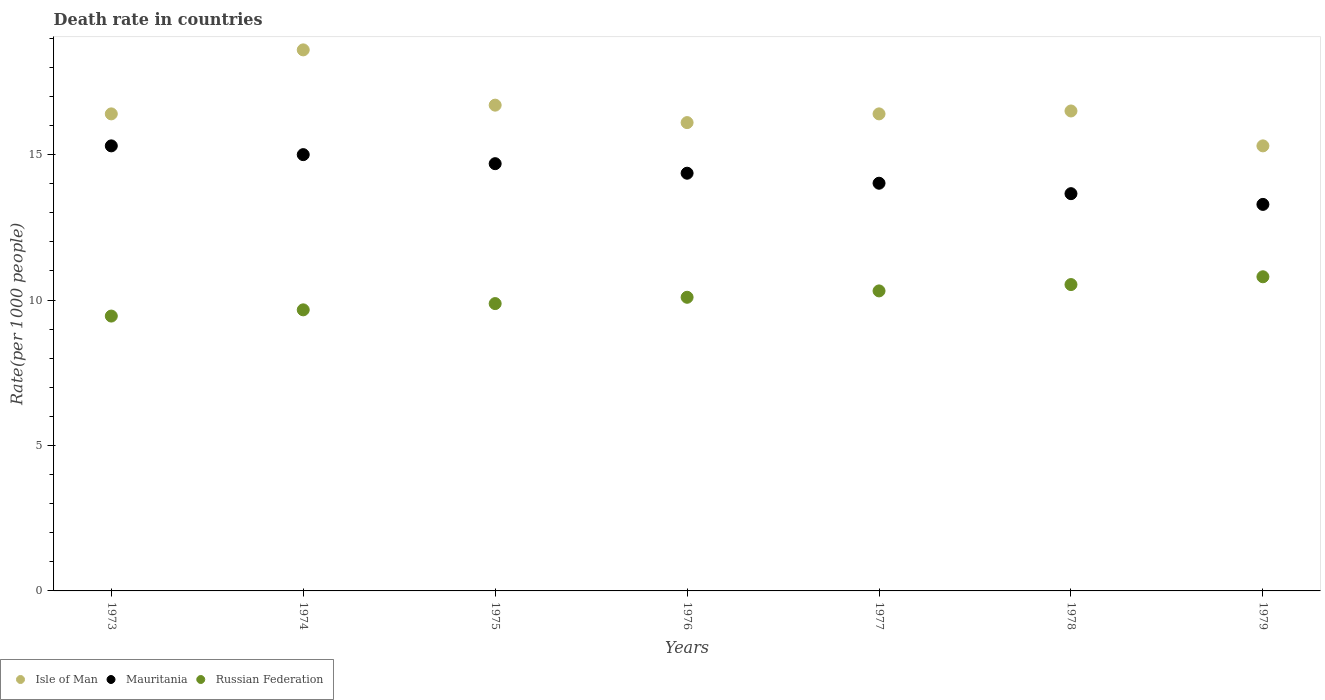How many different coloured dotlines are there?
Your response must be concise. 3. Is the number of dotlines equal to the number of legend labels?
Provide a succinct answer. Yes. What is the death rate in Mauritania in 1977?
Your answer should be very brief. 14.02. Across all years, what is the minimum death rate in Russian Federation?
Your answer should be compact. 9.45. In which year was the death rate in Russian Federation maximum?
Provide a short and direct response. 1979. What is the total death rate in Isle of Man in the graph?
Your answer should be compact. 116. What is the difference between the death rate in Isle of Man in 1973 and that in 1974?
Provide a succinct answer. -2.2. What is the average death rate in Isle of Man per year?
Provide a succinct answer. 16.57. In the year 1976, what is the difference between the death rate in Mauritania and death rate in Russian Federation?
Your answer should be very brief. 4.26. What is the ratio of the death rate in Russian Federation in 1973 to that in 1978?
Make the answer very short. 0.9. Is the death rate in Russian Federation in 1974 less than that in 1978?
Your answer should be very brief. Yes. Is the difference between the death rate in Mauritania in 1973 and 1977 greater than the difference between the death rate in Russian Federation in 1973 and 1977?
Offer a terse response. Yes. What is the difference between the highest and the second highest death rate in Mauritania?
Ensure brevity in your answer.  0.3. What is the difference between the highest and the lowest death rate in Russian Federation?
Ensure brevity in your answer.  1.35. Is the sum of the death rate in Isle of Man in 1973 and 1978 greater than the maximum death rate in Mauritania across all years?
Your answer should be compact. Yes. Is it the case that in every year, the sum of the death rate in Russian Federation and death rate in Mauritania  is greater than the death rate in Isle of Man?
Give a very brief answer. Yes. Does the death rate in Russian Federation monotonically increase over the years?
Ensure brevity in your answer.  Yes. Is the death rate in Isle of Man strictly less than the death rate in Mauritania over the years?
Offer a very short reply. No. How many years are there in the graph?
Your response must be concise. 7. What is the difference between two consecutive major ticks on the Y-axis?
Give a very brief answer. 5. Are the values on the major ticks of Y-axis written in scientific E-notation?
Your response must be concise. No. Where does the legend appear in the graph?
Keep it short and to the point. Bottom left. What is the title of the graph?
Provide a succinct answer. Death rate in countries. Does "Japan" appear as one of the legend labels in the graph?
Your answer should be compact. No. What is the label or title of the X-axis?
Keep it short and to the point. Years. What is the label or title of the Y-axis?
Provide a short and direct response. Rate(per 1000 people). What is the Rate(per 1000 people) of Russian Federation in 1973?
Offer a terse response. 9.45. What is the Rate(per 1000 people) of Mauritania in 1974?
Ensure brevity in your answer.  15. What is the Rate(per 1000 people) in Russian Federation in 1974?
Provide a short and direct response. 9.66. What is the Rate(per 1000 people) of Mauritania in 1975?
Offer a very short reply. 14.69. What is the Rate(per 1000 people) in Russian Federation in 1975?
Ensure brevity in your answer.  9.88. What is the Rate(per 1000 people) of Mauritania in 1976?
Give a very brief answer. 14.36. What is the Rate(per 1000 people) of Russian Federation in 1976?
Offer a very short reply. 10.1. What is the Rate(per 1000 people) in Mauritania in 1977?
Your answer should be compact. 14.02. What is the Rate(per 1000 people) in Russian Federation in 1977?
Your answer should be very brief. 10.31. What is the Rate(per 1000 people) of Isle of Man in 1978?
Make the answer very short. 16.5. What is the Rate(per 1000 people) in Mauritania in 1978?
Offer a terse response. 13.66. What is the Rate(per 1000 people) of Russian Federation in 1978?
Provide a short and direct response. 10.53. What is the Rate(per 1000 people) of Isle of Man in 1979?
Keep it short and to the point. 15.3. What is the Rate(per 1000 people) in Mauritania in 1979?
Give a very brief answer. 13.29. What is the Rate(per 1000 people) of Russian Federation in 1979?
Provide a short and direct response. 10.8. Across all years, what is the maximum Rate(per 1000 people) of Russian Federation?
Keep it short and to the point. 10.8. Across all years, what is the minimum Rate(per 1000 people) in Mauritania?
Make the answer very short. 13.29. Across all years, what is the minimum Rate(per 1000 people) of Russian Federation?
Ensure brevity in your answer.  9.45. What is the total Rate(per 1000 people) in Isle of Man in the graph?
Keep it short and to the point. 116. What is the total Rate(per 1000 people) of Mauritania in the graph?
Your answer should be compact. 100.31. What is the total Rate(per 1000 people) in Russian Federation in the graph?
Offer a very short reply. 70.73. What is the difference between the Rate(per 1000 people) in Mauritania in 1973 and that in 1974?
Provide a succinct answer. 0.3. What is the difference between the Rate(per 1000 people) of Russian Federation in 1973 and that in 1974?
Keep it short and to the point. -0.21. What is the difference between the Rate(per 1000 people) in Mauritania in 1973 and that in 1975?
Make the answer very short. 0.61. What is the difference between the Rate(per 1000 people) in Russian Federation in 1973 and that in 1975?
Make the answer very short. -0.43. What is the difference between the Rate(per 1000 people) of Mauritania in 1973 and that in 1976?
Provide a succinct answer. 0.94. What is the difference between the Rate(per 1000 people) of Russian Federation in 1973 and that in 1976?
Offer a very short reply. -0.65. What is the difference between the Rate(per 1000 people) in Mauritania in 1973 and that in 1977?
Your response must be concise. 1.28. What is the difference between the Rate(per 1000 people) of Russian Federation in 1973 and that in 1977?
Your response must be concise. -0.86. What is the difference between the Rate(per 1000 people) in Isle of Man in 1973 and that in 1978?
Provide a short and direct response. -0.1. What is the difference between the Rate(per 1000 people) of Mauritania in 1973 and that in 1978?
Ensure brevity in your answer.  1.64. What is the difference between the Rate(per 1000 people) of Russian Federation in 1973 and that in 1978?
Offer a very short reply. -1.08. What is the difference between the Rate(per 1000 people) of Mauritania in 1973 and that in 1979?
Your answer should be very brief. 2.01. What is the difference between the Rate(per 1000 people) in Russian Federation in 1973 and that in 1979?
Your answer should be compact. -1.35. What is the difference between the Rate(per 1000 people) in Isle of Man in 1974 and that in 1975?
Give a very brief answer. 1.9. What is the difference between the Rate(per 1000 people) in Mauritania in 1974 and that in 1975?
Make the answer very short. 0.31. What is the difference between the Rate(per 1000 people) of Russian Federation in 1974 and that in 1975?
Your response must be concise. -0.21. What is the difference between the Rate(per 1000 people) of Isle of Man in 1974 and that in 1976?
Offer a terse response. 2.5. What is the difference between the Rate(per 1000 people) of Mauritania in 1974 and that in 1976?
Make the answer very short. 0.64. What is the difference between the Rate(per 1000 people) in Russian Federation in 1974 and that in 1976?
Ensure brevity in your answer.  -0.43. What is the difference between the Rate(per 1000 people) of Russian Federation in 1974 and that in 1977?
Your response must be concise. -0.65. What is the difference between the Rate(per 1000 people) in Mauritania in 1974 and that in 1978?
Keep it short and to the point. 1.34. What is the difference between the Rate(per 1000 people) in Russian Federation in 1974 and that in 1978?
Ensure brevity in your answer.  -0.87. What is the difference between the Rate(per 1000 people) in Mauritania in 1974 and that in 1979?
Make the answer very short. 1.71. What is the difference between the Rate(per 1000 people) in Russian Federation in 1974 and that in 1979?
Provide a succinct answer. -1.14. What is the difference between the Rate(per 1000 people) in Isle of Man in 1975 and that in 1976?
Your answer should be compact. 0.6. What is the difference between the Rate(per 1000 people) of Mauritania in 1975 and that in 1976?
Provide a succinct answer. 0.33. What is the difference between the Rate(per 1000 people) in Russian Federation in 1975 and that in 1976?
Offer a terse response. -0.22. What is the difference between the Rate(per 1000 people) of Isle of Man in 1975 and that in 1977?
Provide a succinct answer. 0.3. What is the difference between the Rate(per 1000 people) in Mauritania in 1975 and that in 1977?
Provide a short and direct response. 0.67. What is the difference between the Rate(per 1000 people) of Russian Federation in 1975 and that in 1977?
Make the answer very short. -0.44. What is the difference between the Rate(per 1000 people) of Mauritania in 1975 and that in 1978?
Your answer should be compact. 1.03. What is the difference between the Rate(per 1000 people) of Russian Federation in 1975 and that in 1978?
Make the answer very short. -0.65. What is the difference between the Rate(per 1000 people) of Mauritania in 1975 and that in 1979?
Give a very brief answer. 1.4. What is the difference between the Rate(per 1000 people) in Russian Federation in 1975 and that in 1979?
Provide a short and direct response. -0.92. What is the difference between the Rate(per 1000 people) of Mauritania in 1976 and that in 1977?
Offer a terse response. 0.34. What is the difference between the Rate(per 1000 people) in Russian Federation in 1976 and that in 1977?
Make the answer very short. -0.22. What is the difference between the Rate(per 1000 people) in Mauritania in 1976 and that in 1978?
Offer a very short reply. 0.7. What is the difference between the Rate(per 1000 people) in Russian Federation in 1976 and that in 1978?
Offer a very short reply. -0.44. What is the difference between the Rate(per 1000 people) in Isle of Man in 1976 and that in 1979?
Your response must be concise. 0.8. What is the difference between the Rate(per 1000 people) of Mauritania in 1976 and that in 1979?
Your answer should be compact. 1.07. What is the difference between the Rate(per 1000 people) in Russian Federation in 1976 and that in 1979?
Give a very brief answer. -0.7. What is the difference between the Rate(per 1000 people) of Mauritania in 1977 and that in 1978?
Give a very brief answer. 0.36. What is the difference between the Rate(per 1000 people) in Russian Federation in 1977 and that in 1978?
Keep it short and to the point. -0.22. What is the difference between the Rate(per 1000 people) in Mauritania in 1977 and that in 1979?
Keep it short and to the point. 0.73. What is the difference between the Rate(per 1000 people) in Russian Federation in 1977 and that in 1979?
Offer a very short reply. -0.49. What is the difference between the Rate(per 1000 people) of Isle of Man in 1978 and that in 1979?
Your answer should be very brief. 1.2. What is the difference between the Rate(per 1000 people) in Mauritania in 1978 and that in 1979?
Your answer should be compact. 0.37. What is the difference between the Rate(per 1000 people) of Russian Federation in 1978 and that in 1979?
Offer a very short reply. -0.27. What is the difference between the Rate(per 1000 people) in Isle of Man in 1973 and the Rate(per 1000 people) in Mauritania in 1974?
Provide a short and direct response. 1.4. What is the difference between the Rate(per 1000 people) of Isle of Man in 1973 and the Rate(per 1000 people) of Russian Federation in 1974?
Your answer should be very brief. 6.74. What is the difference between the Rate(per 1000 people) in Mauritania in 1973 and the Rate(per 1000 people) in Russian Federation in 1974?
Provide a succinct answer. 5.64. What is the difference between the Rate(per 1000 people) of Isle of Man in 1973 and the Rate(per 1000 people) of Mauritania in 1975?
Provide a short and direct response. 1.71. What is the difference between the Rate(per 1000 people) of Isle of Man in 1973 and the Rate(per 1000 people) of Russian Federation in 1975?
Offer a terse response. 6.52. What is the difference between the Rate(per 1000 people) in Mauritania in 1973 and the Rate(per 1000 people) in Russian Federation in 1975?
Provide a succinct answer. 5.42. What is the difference between the Rate(per 1000 people) of Isle of Man in 1973 and the Rate(per 1000 people) of Mauritania in 1976?
Provide a short and direct response. 2.04. What is the difference between the Rate(per 1000 people) in Isle of Man in 1973 and the Rate(per 1000 people) in Russian Federation in 1976?
Provide a short and direct response. 6.3. What is the difference between the Rate(per 1000 people) of Mauritania in 1973 and the Rate(per 1000 people) of Russian Federation in 1976?
Give a very brief answer. 5.21. What is the difference between the Rate(per 1000 people) in Isle of Man in 1973 and the Rate(per 1000 people) in Mauritania in 1977?
Your response must be concise. 2.38. What is the difference between the Rate(per 1000 people) of Isle of Man in 1973 and the Rate(per 1000 people) of Russian Federation in 1977?
Your response must be concise. 6.09. What is the difference between the Rate(per 1000 people) in Mauritania in 1973 and the Rate(per 1000 people) in Russian Federation in 1977?
Give a very brief answer. 4.99. What is the difference between the Rate(per 1000 people) in Isle of Man in 1973 and the Rate(per 1000 people) in Mauritania in 1978?
Your answer should be very brief. 2.74. What is the difference between the Rate(per 1000 people) in Isle of Man in 1973 and the Rate(per 1000 people) in Russian Federation in 1978?
Your answer should be compact. 5.87. What is the difference between the Rate(per 1000 people) of Mauritania in 1973 and the Rate(per 1000 people) of Russian Federation in 1978?
Provide a short and direct response. 4.77. What is the difference between the Rate(per 1000 people) of Isle of Man in 1973 and the Rate(per 1000 people) of Mauritania in 1979?
Your answer should be very brief. 3.11. What is the difference between the Rate(per 1000 people) in Isle of Man in 1973 and the Rate(per 1000 people) in Russian Federation in 1979?
Provide a short and direct response. 5.6. What is the difference between the Rate(per 1000 people) in Mauritania in 1973 and the Rate(per 1000 people) in Russian Federation in 1979?
Offer a very short reply. 4.5. What is the difference between the Rate(per 1000 people) in Isle of Man in 1974 and the Rate(per 1000 people) in Mauritania in 1975?
Provide a short and direct response. 3.91. What is the difference between the Rate(per 1000 people) in Isle of Man in 1974 and the Rate(per 1000 people) in Russian Federation in 1975?
Your answer should be very brief. 8.72. What is the difference between the Rate(per 1000 people) of Mauritania in 1974 and the Rate(per 1000 people) of Russian Federation in 1975?
Provide a succinct answer. 5.12. What is the difference between the Rate(per 1000 people) in Isle of Man in 1974 and the Rate(per 1000 people) in Mauritania in 1976?
Offer a terse response. 4.24. What is the difference between the Rate(per 1000 people) of Isle of Man in 1974 and the Rate(per 1000 people) of Russian Federation in 1976?
Offer a terse response. 8.51. What is the difference between the Rate(per 1000 people) of Mauritania in 1974 and the Rate(per 1000 people) of Russian Federation in 1976?
Provide a short and direct response. 4.9. What is the difference between the Rate(per 1000 people) in Isle of Man in 1974 and the Rate(per 1000 people) in Mauritania in 1977?
Provide a short and direct response. 4.58. What is the difference between the Rate(per 1000 people) in Isle of Man in 1974 and the Rate(per 1000 people) in Russian Federation in 1977?
Keep it short and to the point. 8.29. What is the difference between the Rate(per 1000 people) in Mauritania in 1974 and the Rate(per 1000 people) in Russian Federation in 1977?
Your answer should be very brief. 4.68. What is the difference between the Rate(per 1000 people) in Isle of Man in 1974 and the Rate(per 1000 people) in Mauritania in 1978?
Your answer should be compact. 4.94. What is the difference between the Rate(per 1000 people) of Isle of Man in 1974 and the Rate(per 1000 people) of Russian Federation in 1978?
Ensure brevity in your answer.  8.07. What is the difference between the Rate(per 1000 people) of Mauritania in 1974 and the Rate(per 1000 people) of Russian Federation in 1978?
Provide a succinct answer. 4.47. What is the difference between the Rate(per 1000 people) of Isle of Man in 1974 and the Rate(per 1000 people) of Mauritania in 1979?
Make the answer very short. 5.31. What is the difference between the Rate(per 1000 people) of Mauritania in 1974 and the Rate(per 1000 people) of Russian Federation in 1979?
Your response must be concise. 4.2. What is the difference between the Rate(per 1000 people) in Isle of Man in 1975 and the Rate(per 1000 people) in Mauritania in 1976?
Make the answer very short. 2.34. What is the difference between the Rate(per 1000 people) in Isle of Man in 1975 and the Rate(per 1000 people) in Russian Federation in 1976?
Provide a short and direct response. 6.61. What is the difference between the Rate(per 1000 people) in Mauritania in 1975 and the Rate(per 1000 people) in Russian Federation in 1976?
Offer a very short reply. 4.59. What is the difference between the Rate(per 1000 people) in Isle of Man in 1975 and the Rate(per 1000 people) in Mauritania in 1977?
Offer a terse response. 2.68. What is the difference between the Rate(per 1000 people) of Isle of Man in 1975 and the Rate(per 1000 people) of Russian Federation in 1977?
Keep it short and to the point. 6.39. What is the difference between the Rate(per 1000 people) of Mauritania in 1975 and the Rate(per 1000 people) of Russian Federation in 1977?
Your response must be concise. 4.37. What is the difference between the Rate(per 1000 people) of Isle of Man in 1975 and the Rate(per 1000 people) of Mauritania in 1978?
Your response must be concise. 3.04. What is the difference between the Rate(per 1000 people) of Isle of Man in 1975 and the Rate(per 1000 people) of Russian Federation in 1978?
Offer a very short reply. 6.17. What is the difference between the Rate(per 1000 people) in Mauritania in 1975 and the Rate(per 1000 people) in Russian Federation in 1978?
Offer a very short reply. 4.16. What is the difference between the Rate(per 1000 people) of Isle of Man in 1975 and the Rate(per 1000 people) of Mauritania in 1979?
Keep it short and to the point. 3.41. What is the difference between the Rate(per 1000 people) of Mauritania in 1975 and the Rate(per 1000 people) of Russian Federation in 1979?
Provide a succinct answer. 3.89. What is the difference between the Rate(per 1000 people) in Isle of Man in 1976 and the Rate(per 1000 people) in Mauritania in 1977?
Offer a very short reply. 2.08. What is the difference between the Rate(per 1000 people) of Isle of Man in 1976 and the Rate(per 1000 people) of Russian Federation in 1977?
Offer a very short reply. 5.79. What is the difference between the Rate(per 1000 people) of Mauritania in 1976 and the Rate(per 1000 people) of Russian Federation in 1977?
Provide a short and direct response. 4.05. What is the difference between the Rate(per 1000 people) of Isle of Man in 1976 and the Rate(per 1000 people) of Mauritania in 1978?
Your answer should be compact. 2.44. What is the difference between the Rate(per 1000 people) in Isle of Man in 1976 and the Rate(per 1000 people) in Russian Federation in 1978?
Your answer should be very brief. 5.57. What is the difference between the Rate(per 1000 people) in Mauritania in 1976 and the Rate(per 1000 people) in Russian Federation in 1978?
Offer a terse response. 3.83. What is the difference between the Rate(per 1000 people) of Isle of Man in 1976 and the Rate(per 1000 people) of Mauritania in 1979?
Your response must be concise. 2.81. What is the difference between the Rate(per 1000 people) in Mauritania in 1976 and the Rate(per 1000 people) in Russian Federation in 1979?
Ensure brevity in your answer.  3.56. What is the difference between the Rate(per 1000 people) of Isle of Man in 1977 and the Rate(per 1000 people) of Mauritania in 1978?
Your answer should be very brief. 2.74. What is the difference between the Rate(per 1000 people) in Isle of Man in 1977 and the Rate(per 1000 people) in Russian Federation in 1978?
Your answer should be very brief. 5.87. What is the difference between the Rate(per 1000 people) of Mauritania in 1977 and the Rate(per 1000 people) of Russian Federation in 1978?
Your response must be concise. 3.48. What is the difference between the Rate(per 1000 people) in Isle of Man in 1977 and the Rate(per 1000 people) in Mauritania in 1979?
Offer a very short reply. 3.11. What is the difference between the Rate(per 1000 people) in Isle of Man in 1977 and the Rate(per 1000 people) in Russian Federation in 1979?
Offer a very short reply. 5.6. What is the difference between the Rate(per 1000 people) in Mauritania in 1977 and the Rate(per 1000 people) in Russian Federation in 1979?
Offer a terse response. 3.22. What is the difference between the Rate(per 1000 people) of Isle of Man in 1978 and the Rate(per 1000 people) of Mauritania in 1979?
Your answer should be compact. 3.21. What is the difference between the Rate(per 1000 people) in Mauritania in 1978 and the Rate(per 1000 people) in Russian Federation in 1979?
Ensure brevity in your answer.  2.86. What is the average Rate(per 1000 people) of Isle of Man per year?
Your answer should be compact. 16.57. What is the average Rate(per 1000 people) in Mauritania per year?
Offer a terse response. 14.33. What is the average Rate(per 1000 people) in Russian Federation per year?
Keep it short and to the point. 10.1. In the year 1973, what is the difference between the Rate(per 1000 people) of Isle of Man and Rate(per 1000 people) of Mauritania?
Offer a very short reply. 1.1. In the year 1973, what is the difference between the Rate(per 1000 people) of Isle of Man and Rate(per 1000 people) of Russian Federation?
Your answer should be compact. 6.95. In the year 1973, what is the difference between the Rate(per 1000 people) of Mauritania and Rate(per 1000 people) of Russian Federation?
Keep it short and to the point. 5.85. In the year 1974, what is the difference between the Rate(per 1000 people) in Isle of Man and Rate(per 1000 people) in Mauritania?
Your response must be concise. 3.6. In the year 1974, what is the difference between the Rate(per 1000 people) in Isle of Man and Rate(per 1000 people) in Russian Federation?
Your response must be concise. 8.94. In the year 1974, what is the difference between the Rate(per 1000 people) in Mauritania and Rate(per 1000 people) in Russian Federation?
Your response must be concise. 5.34. In the year 1975, what is the difference between the Rate(per 1000 people) in Isle of Man and Rate(per 1000 people) in Mauritania?
Your response must be concise. 2.01. In the year 1975, what is the difference between the Rate(per 1000 people) of Isle of Man and Rate(per 1000 people) of Russian Federation?
Keep it short and to the point. 6.82. In the year 1975, what is the difference between the Rate(per 1000 people) in Mauritania and Rate(per 1000 people) in Russian Federation?
Your answer should be compact. 4.81. In the year 1976, what is the difference between the Rate(per 1000 people) of Isle of Man and Rate(per 1000 people) of Mauritania?
Your response must be concise. 1.74. In the year 1976, what is the difference between the Rate(per 1000 people) in Isle of Man and Rate(per 1000 people) in Russian Federation?
Your answer should be very brief. 6. In the year 1976, what is the difference between the Rate(per 1000 people) of Mauritania and Rate(per 1000 people) of Russian Federation?
Offer a terse response. 4.26. In the year 1977, what is the difference between the Rate(per 1000 people) of Isle of Man and Rate(per 1000 people) of Mauritania?
Your response must be concise. 2.38. In the year 1977, what is the difference between the Rate(per 1000 people) of Isle of Man and Rate(per 1000 people) of Russian Federation?
Make the answer very short. 6.09. In the year 1977, what is the difference between the Rate(per 1000 people) in Mauritania and Rate(per 1000 people) in Russian Federation?
Your answer should be very brief. 3.7. In the year 1978, what is the difference between the Rate(per 1000 people) in Isle of Man and Rate(per 1000 people) in Mauritania?
Your answer should be compact. 2.84. In the year 1978, what is the difference between the Rate(per 1000 people) in Isle of Man and Rate(per 1000 people) in Russian Federation?
Your answer should be compact. 5.97. In the year 1978, what is the difference between the Rate(per 1000 people) in Mauritania and Rate(per 1000 people) in Russian Federation?
Keep it short and to the point. 3.12. In the year 1979, what is the difference between the Rate(per 1000 people) in Isle of Man and Rate(per 1000 people) in Mauritania?
Ensure brevity in your answer.  2.01. In the year 1979, what is the difference between the Rate(per 1000 people) in Isle of Man and Rate(per 1000 people) in Russian Federation?
Your response must be concise. 4.5. In the year 1979, what is the difference between the Rate(per 1000 people) in Mauritania and Rate(per 1000 people) in Russian Federation?
Keep it short and to the point. 2.49. What is the ratio of the Rate(per 1000 people) of Isle of Man in 1973 to that in 1974?
Your response must be concise. 0.88. What is the ratio of the Rate(per 1000 people) of Mauritania in 1973 to that in 1974?
Make the answer very short. 1.02. What is the ratio of the Rate(per 1000 people) of Russian Federation in 1973 to that in 1974?
Make the answer very short. 0.98. What is the ratio of the Rate(per 1000 people) in Isle of Man in 1973 to that in 1975?
Ensure brevity in your answer.  0.98. What is the ratio of the Rate(per 1000 people) of Mauritania in 1973 to that in 1975?
Your response must be concise. 1.04. What is the ratio of the Rate(per 1000 people) of Russian Federation in 1973 to that in 1975?
Ensure brevity in your answer.  0.96. What is the ratio of the Rate(per 1000 people) of Isle of Man in 1973 to that in 1976?
Offer a terse response. 1.02. What is the ratio of the Rate(per 1000 people) of Mauritania in 1973 to that in 1976?
Your answer should be very brief. 1.07. What is the ratio of the Rate(per 1000 people) in Russian Federation in 1973 to that in 1976?
Make the answer very short. 0.94. What is the ratio of the Rate(per 1000 people) in Mauritania in 1973 to that in 1977?
Provide a short and direct response. 1.09. What is the ratio of the Rate(per 1000 people) of Russian Federation in 1973 to that in 1977?
Your answer should be very brief. 0.92. What is the ratio of the Rate(per 1000 people) in Mauritania in 1973 to that in 1978?
Give a very brief answer. 1.12. What is the ratio of the Rate(per 1000 people) of Russian Federation in 1973 to that in 1978?
Ensure brevity in your answer.  0.9. What is the ratio of the Rate(per 1000 people) of Isle of Man in 1973 to that in 1979?
Provide a short and direct response. 1.07. What is the ratio of the Rate(per 1000 people) in Mauritania in 1973 to that in 1979?
Make the answer very short. 1.15. What is the ratio of the Rate(per 1000 people) in Russian Federation in 1973 to that in 1979?
Keep it short and to the point. 0.87. What is the ratio of the Rate(per 1000 people) in Isle of Man in 1974 to that in 1975?
Ensure brevity in your answer.  1.11. What is the ratio of the Rate(per 1000 people) of Mauritania in 1974 to that in 1975?
Make the answer very short. 1.02. What is the ratio of the Rate(per 1000 people) in Russian Federation in 1974 to that in 1975?
Give a very brief answer. 0.98. What is the ratio of the Rate(per 1000 people) in Isle of Man in 1974 to that in 1976?
Make the answer very short. 1.16. What is the ratio of the Rate(per 1000 people) in Mauritania in 1974 to that in 1976?
Your answer should be very brief. 1.04. What is the ratio of the Rate(per 1000 people) in Russian Federation in 1974 to that in 1976?
Your answer should be compact. 0.96. What is the ratio of the Rate(per 1000 people) of Isle of Man in 1974 to that in 1977?
Offer a terse response. 1.13. What is the ratio of the Rate(per 1000 people) of Mauritania in 1974 to that in 1977?
Give a very brief answer. 1.07. What is the ratio of the Rate(per 1000 people) of Russian Federation in 1974 to that in 1977?
Offer a very short reply. 0.94. What is the ratio of the Rate(per 1000 people) of Isle of Man in 1974 to that in 1978?
Ensure brevity in your answer.  1.13. What is the ratio of the Rate(per 1000 people) of Mauritania in 1974 to that in 1978?
Your response must be concise. 1.1. What is the ratio of the Rate(per 1000 people) of Russian Federation in 1974 to that in 1978?
Keep it short and to the point. 0.92. What is the ratio of the Rate(per 1000 people) of Isle of Man in 1974 to that in 1979?
Your response must be concise. 1.22. What is the ratio of the Rate(per 1000 people) of Mauritania in 1974 to that in 1979?
Offer a very short reply. 1.13. What is the ratio of the Rate(per 1000 people) of Russian Federation in 1974 to that in 1979?
Provide a succinct answer. 0.89. What is the ratio of the Rate(per 1000 people) of Isle of Man in 1975 to that in 1976?
Make the answer very short. 1.04. What is the ratio of the Rate(per 1000 people) of Mauritania in 1975 to that in 1976?
Provide a short and direct response. 1.02. What is the ratio of the Rate(per 1000 people) in Russian Federation in 1975 to that in 1976?
Offer a terse response. 0.98. What is the ratio of the Rate(per 1000 people) in Isle of Man in 1975 to that in 1977?
Make the answer very short. 1.02. What is the ratio of the Rate(per 1000 people) in Mauritania in 1975 to that in 1977?
Offer a terse response. 1.05. What is the ratio of the Rate(per 1000 people) of Russian Federation in 1975 to that in 1977?
Your answer should be very brief. 0.96. What is the ratio of the Rate(per 1000 people) in Isle of Man in 1975 to that in 1978?
Offer a very short reply. 1.01. What is the ratio of the Rate(per 1000 people) of Mauritania in 1975 to that in 1978?
Provide a succinct answer. 1.08. What is the ratio of the Rate(per 1000 people) in Russian Federation in 1975 to that in 1978?
Make the answer very short. 0.94. What is the ratio of the Rate(per 1000 people) of Isle of Man in 1975 to that in 1979?
Make the answer very short. 1.09. What is the ratio of the Rate(per 1000 people) of Mauritania in 1975 to that in 1979?
Offer a very short reply. 1.11. What is the ratio of the Rate(per 1000 people) of Russian Federation in 1975 to that in 1979?
Your answer should be very brief. 0.91. What is the ratio of the Rate(per 1000 people) in Isle of Man in 1976 to that in 1977?
Ensure brevity in your answer.  0.98. What is the ratio of the Rate(per 1000 people) in Mauritania in 1976 to that in 1977?
Give a very brief answer. 1.02. What is the ratio of the Rate(per 1000 people) of Russian Federation in 1976 to that in 1977?
Keep it short and to the point. 0.98. What is the ratio of the Rate(per 1000 people) in Isle of Man in 1976 to that in 1978?
Give a very brief answer. 0.98. What is the ratio of the Rate(per 1000 people) of Mauritania in 1976 to that in 1978?
Ensure brevity in your answer.  1.05. What is the ratio of the Rate(per 1000 people) of Russian Federation in 1976 to that in 1978?
Your answer should be compact. 0.96. What is the ratio of the Rate(per 1000 people) of Isle of Man in 1976 to that in 1979?
Your answer should be compact. 1.05. What is the ratio of the Rate(per 1000 people) of Mauritania in 1976 to that in 1979?
Offer a terse response. 1.08. What is the ratio of the Rate(per 1000 people) in Russian Federation in 1976 to that in 1979?
Your response must be concise. 0.93. What is the ratio of the Rate(per 1000 people) of Isle of Man in 1977 to that in 1978?
Your response must be concise. 0.99. What is the ratio of the Rate(per 1000 people) of Mauritania in 1977 to that in 1978?
Your response must be concise. 1.03. What is the ratio of the Rate(per 1000 people) of Russian Federation in 1977 to that in 1978?
Offer a terse response. 0.98. What is the ratio of the Rate(per 1000 people) in Isle of Man in 1977 to that in 1979?
Make the answer very short. 1.07. What is the ratio of the Rate(per 1000 people) in Mauritania in 1977 to that in 1979?
Your response must be concise. 1.05. What is the ratio of the Rate(per 1000 people) of Russian Federation in 1977 to that in 1979?
Your answer should be compact. 0.95. What is the ratio of the Rate(per 1000 people) of Isle of Man in 1978 to that in 1979?
Make the answer very short. 1.08. What is the ratio of the Rate(per 1000 people) of Mauritania in 1978 to that in 1979?
Offer a terse response. 1.03. What is the ratio of the Rate(per 1000 people) of Russian Federation in 1978 to that in 1979?
Provide a succinct answer. 0.98. What is the difference between the highest and the second highest Rate(per 1000 people) in Isle of Man?
Make the answer very short. 1.9. What is the difference between the highest and the second highest Rate(per 1000 people) in Mauritania?
Provide a succinct answer. 0.3. What is the difference between the highest and the second highest Rate(per 1000 people) in Russian Federation?
Ensure brevity in your answer.  0.27. What is the difference between the highest and the lowest Rate(per 1000 people) in Mauritania?
Provide a short and direct response. 2.01. What is the difference between the highest and the lowest Rate(per 1000 people) in Russian Federation?
Give a very brief answer. 1.35. 